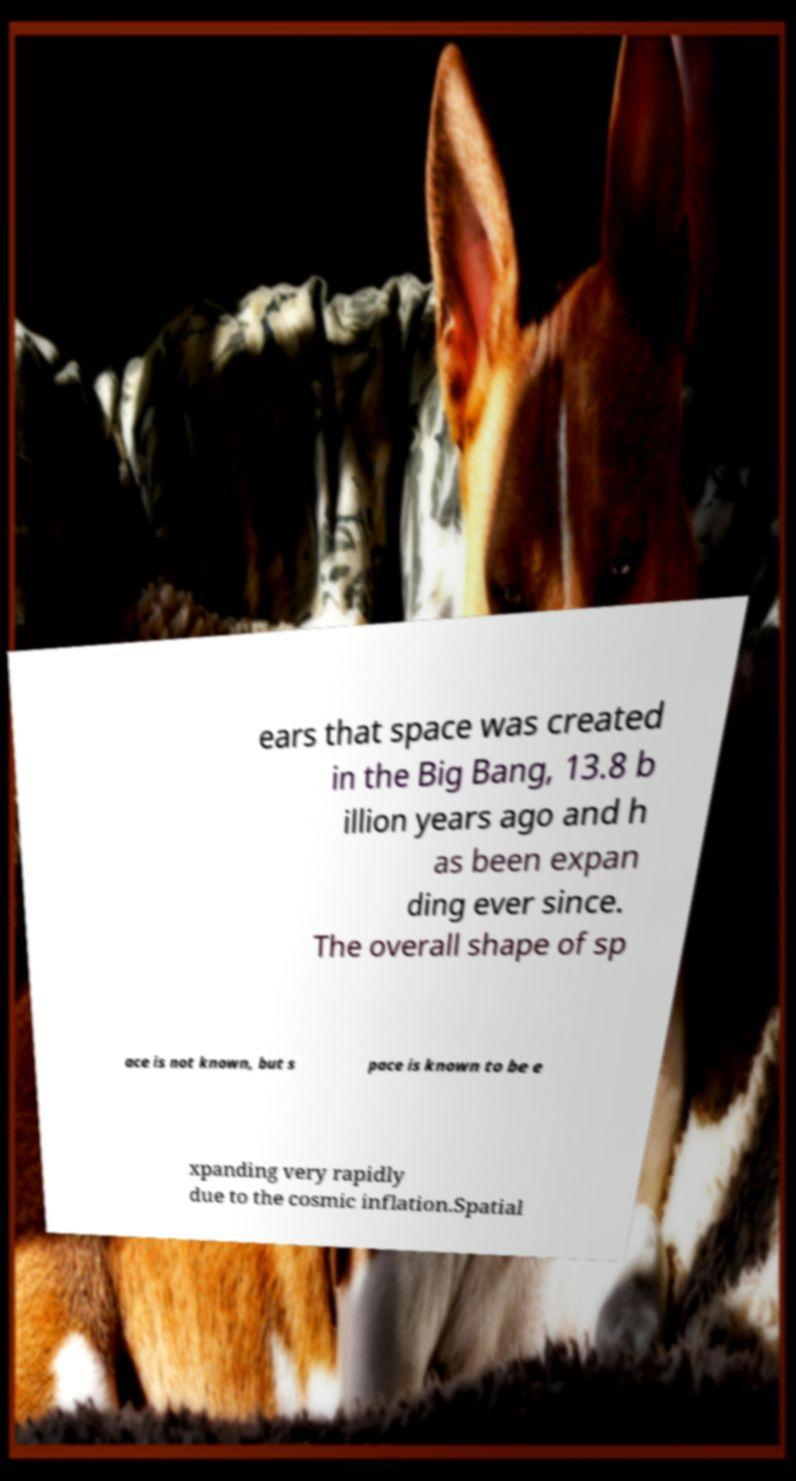There's text embedded in this image that I need extracted. Can you transcribe it verbatim? ears that space was created in the Big Bang, 13.8 b illion years ago and h as been expan ding ever since. The overall shape of sp ace is not known, but s pace is known to be e xpanding very rapidly due to the cosmic inflation.Spatial 